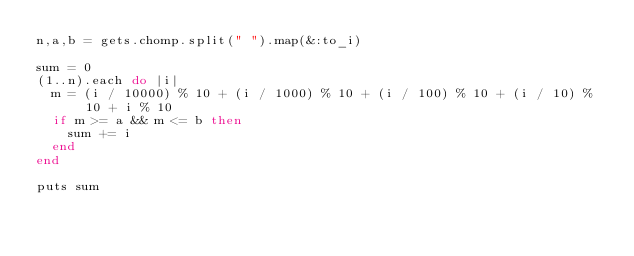Convert code to text. <code><loc_0><loc_0><loc_500><loc_500><_Ruby_>n,a,b = gets.chomp.split(" ").map(&:to_i)

sum = 0
(1..n).each do |i|
  m = (i / 10000) % 10 + (i / 1000) % 10 + (i / 100) % 10 + (i / 10) % 10 + i % 10
  if m >= a && m <= b then
    sum += i
  end
end

puts sum
</code> 